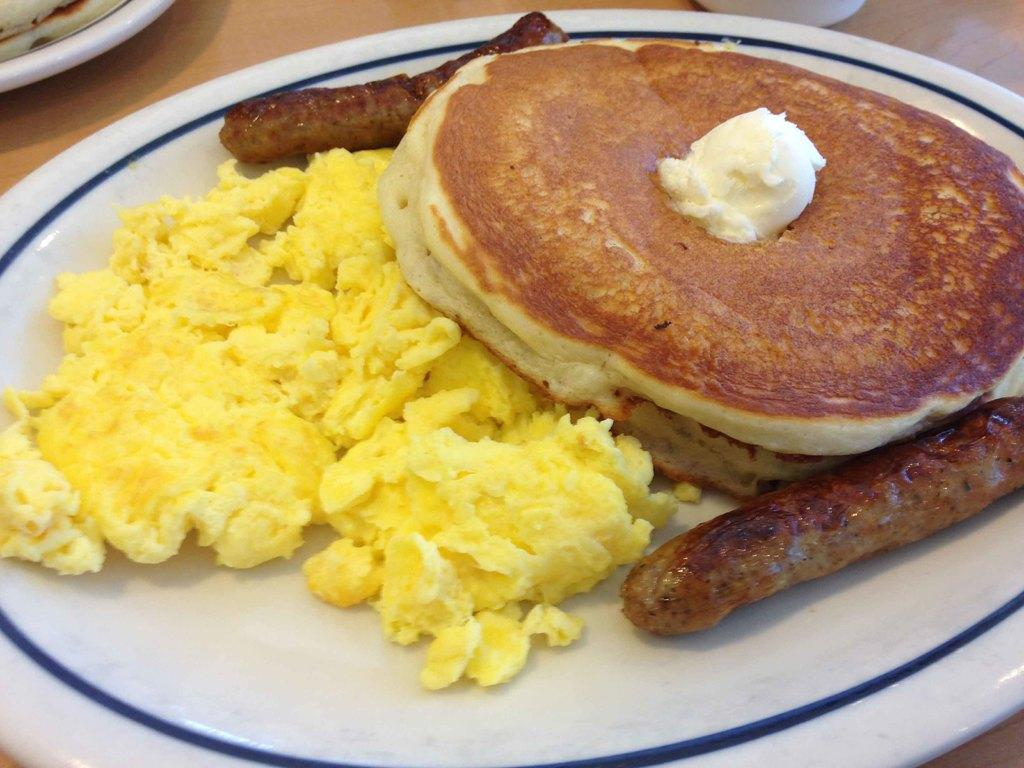What objects are on the table in the image? There are plates on the table in the image. What is on the plates? Food items are present on the plates. Can you describe the setting where the table is located? The image may have been taken in a room. What type of string is being used by the team on the road in the image? There is no team or road present in the image; it features plates with food items on a table. 